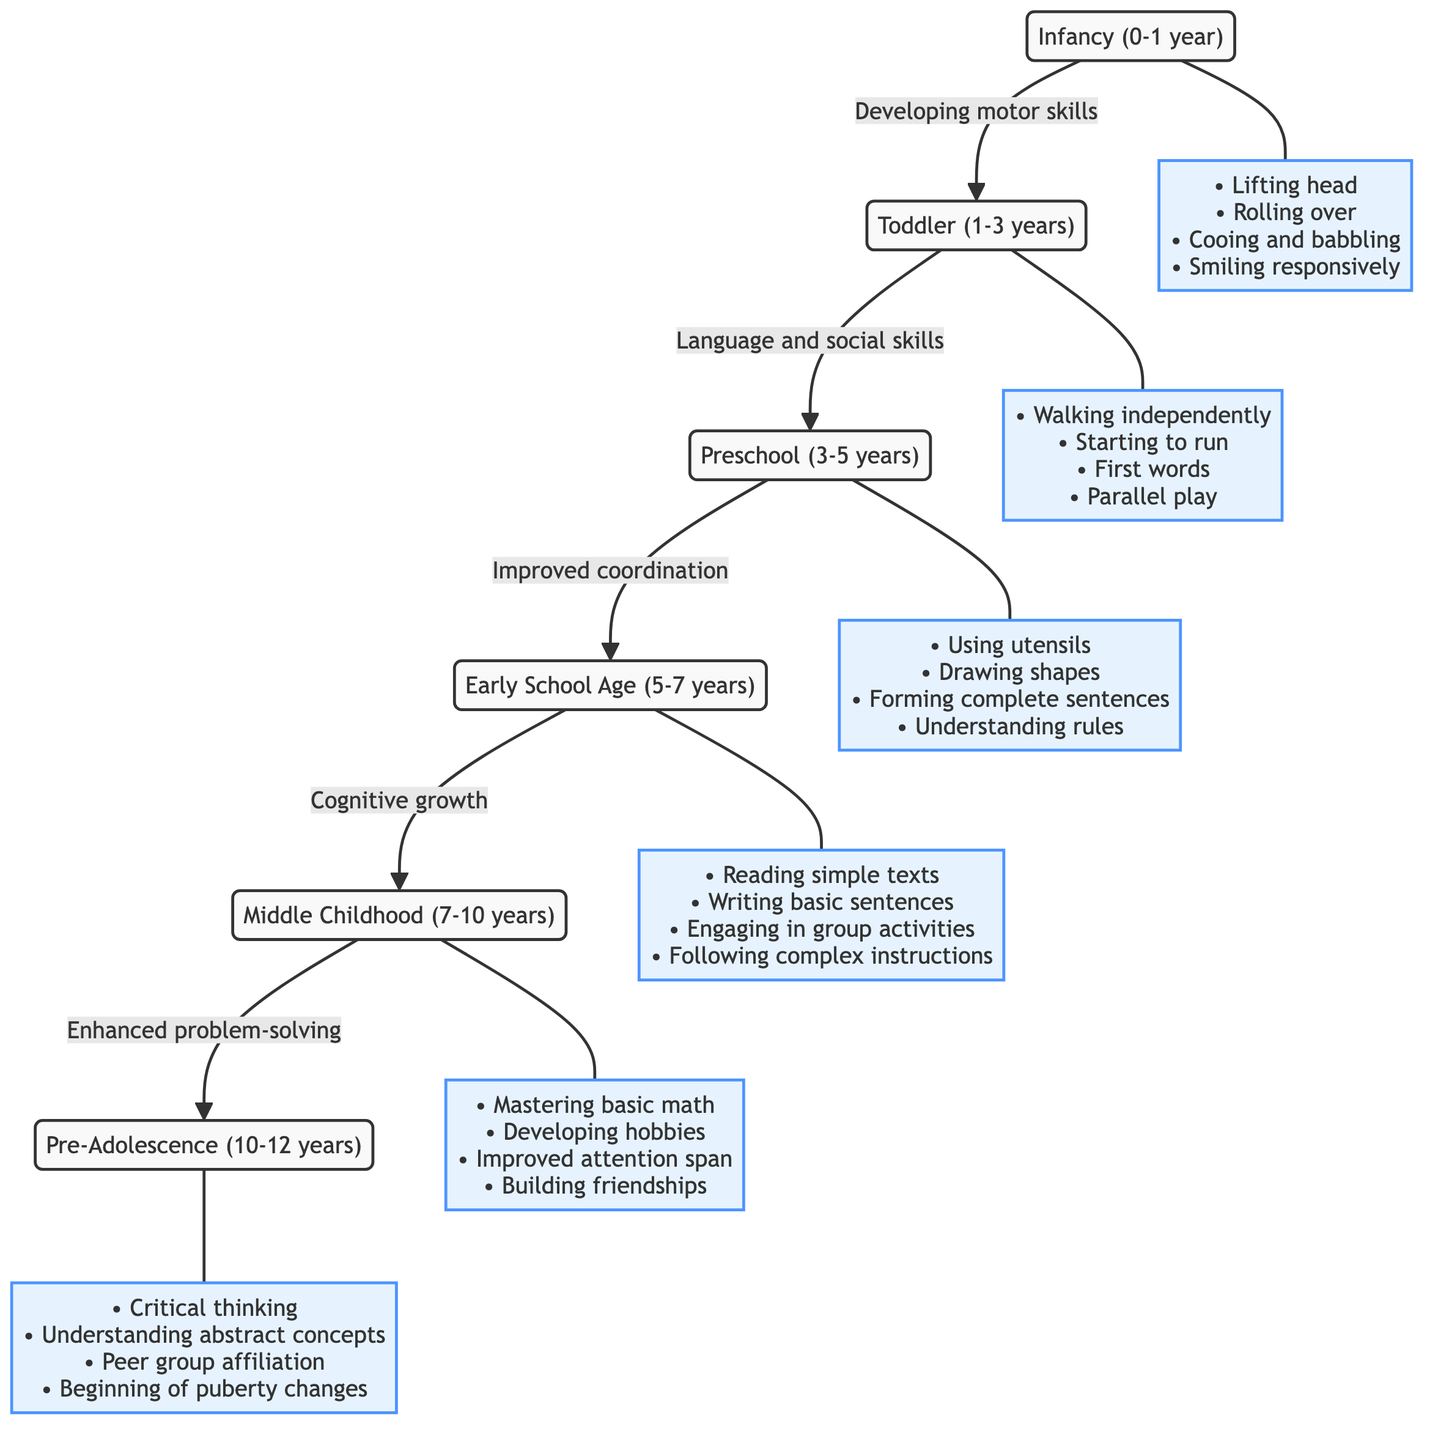What is the age range for the Toddler stage? The diagram indicates that the Toddler stage encompasses ages 1 to 3 years.
Answer: 1-3 years What key milestone is associated with Infancy? The milestone associated with Infancy includes lifting head, rolling over, cooing, and babbling.
Answer: Lifting head What comes after Middle Childhood in the stages? By following the arrows in the diagram, Pre-Adolescence comes after Middle Childhood.
Answer: Pre-Adolescence How many total stages are displayed in the diagram? Counting the stages listed in the diagram, there are six stages in total: Infancy, Toddler, Preschool, Early School Age, Middle Childhood, and Pre-Adolescence.
Answer: 6 What milestone is achieved during Early School Age? The milestone during Early School Age involves reading simple texts, which indicates cognitive development during this period.
Answer: Reading simple texts Which stage involves understanding abstract concepts? By checking the diagram, Pre-Adolescence is the stage where children start to understand abstract concepts.
Answer: Pre-Adolescence Which two stages are connected by "Cognitive growth"? From the flow of the diagram, Early School Age and Middle Childhood are connected by "Cognitive growth."
Answer: Early School Age and Middle Childhood What is the first milestone mentioned in the Toddler stage? The first milestone in the Toddler stage includes walking independently, demonstrating significant physical development.
Answer: Walking independently What major developmental change begins in Pre-Adolescence? The diagram states that the beginning of puberty changes marks a significant developmental change in the Pre-Adolescence stage.
Answer: Beginning of puberty changes 